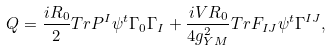Convert formula to latex. <formula><loc_0><loc_0><loc_500><loc_500>Q = \frac { i R _ { 0 } } { 2 } T r P ^ { I } \psi ^ { t } \Gamma _ { 0 } \Gamma _ { I } + \frac { i V R _ { 0 } } { 4 g _ { Y M } ^ { 2 } } T r F _ { I J } \psi ^ { t } \Gamma ^ { I J } ,</formula> 